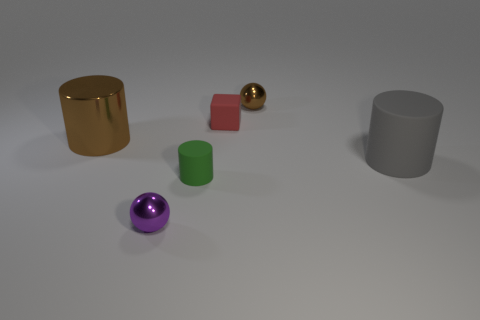Add 2 brown metal balls. How many objects exist? 8 Subtract all spheres. How many objects are left? 4 Subtract all green rubber cylinders. Subtract all purple objects. How many objects are left? 4 Add 5 tiny purple spheres. How many tiny purple spheres are left? 6 Add 5 rubber cubes. How many rubber cubes exist? 6 Subtract 0 gray cubes. How many objects are left? 6 